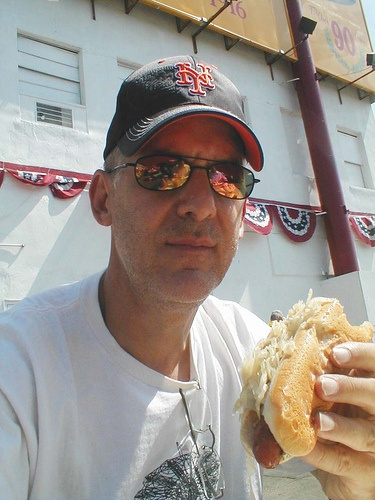Describe the objects in this image and their specific colors. I can see people in darkgray, lightgray, gray, and brown tones, hot dog in darkgray, tan, and beige tones, and sandwich in darkgray, tan, and beige tones in this image. 